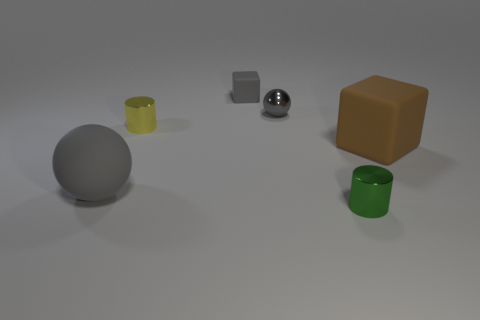What number of other balls are the same color as the tiny sphere?
Your response must be concise. 1. Are there any metal balls that have the same size as the brown matte block?
Keep it short and to the point. No. How many objects are small metal objects or gray things?
Keep it short and to the point. 5. There is a gray matte object that is in front of the big brown rubber object; is it the same size as the cube that is to the right of the green cylinder?
Offer a terse response. Yes. Is there another large gray object that has the same shape as the gray shiny thing?
Give a very brief answer. Yes. Are there fewer small cylinders in front of the yellow metallic object than metal balls?
Offer a very short reply. No. Does the large brown object have the same shape as the tiny gray matte thing?
Your response must be concise. Yes. What size is the object in front of the large gray ball?
Offer a terse response. Small. The yellow cylinder that is the same material as the small gray ball is what size?
Ensure brevity in your answer.  Small. Is the number of things less than the number of gray balls?
Offer a terse response. No. 